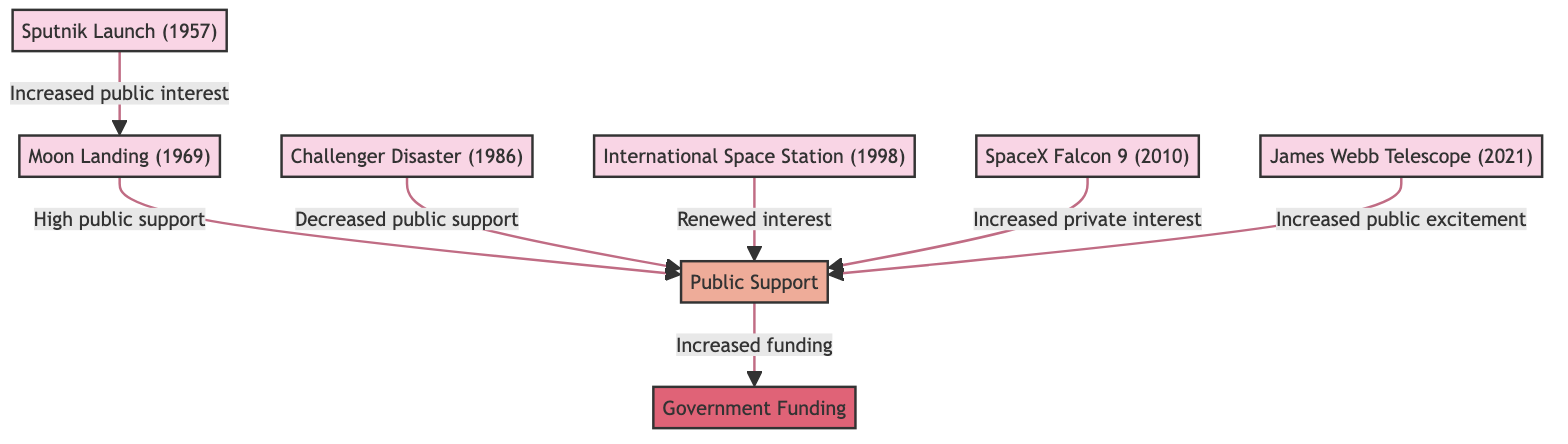What event is linked to increased public interest in space exploration? The diagram indicates that the "Sputnik Launch (1957)" event is directly connected to the increase in public interest, leading to the "Moon Landing (1969)."
Answer: Sputnik Launch How many events influence public support in the diagram? By reviewing the diagram, we can identify seven events listed: Sputnik Launch, Moon Landing, Shuttle Challenger, International Space Station, SpaceX Falcon, and James Webb Telescope.
Answer: 6 What type of sentiment is associated with the Challenger Disaster? The diagram clearly states that the "Challenger Disaster (1986)" resulted in "Decreased public support," demonstrating a negative sentiment connection.
Answer: Decreased public support Which event led from public support to increased funding? The diagram shows that the "Public Support" node has a direct connection to "Government Funding," indicating that high public support led to increased funding following the "Moon Landing (1969)."
Answer: Moon Landing What effect did the SpaceX Falcon 9 event have on public sentiment? According to the diagram, the "SpaceX Falcon 9 (2010)" event created "Increased private interest," which in turn positively affected public sentiment, signifying an engaging event in the trajectory of public sentiment.
Answer: Increased private interest What is the relationship between the Moon Landing and Government Funding? The relationship flows from the "Moon Landing" to "Public Support," which then results in "Increased funding," demonstrating a direct pathway that links public sentiment generated by the moon landing to government investment in space exploration.
Answer: Increased funding 